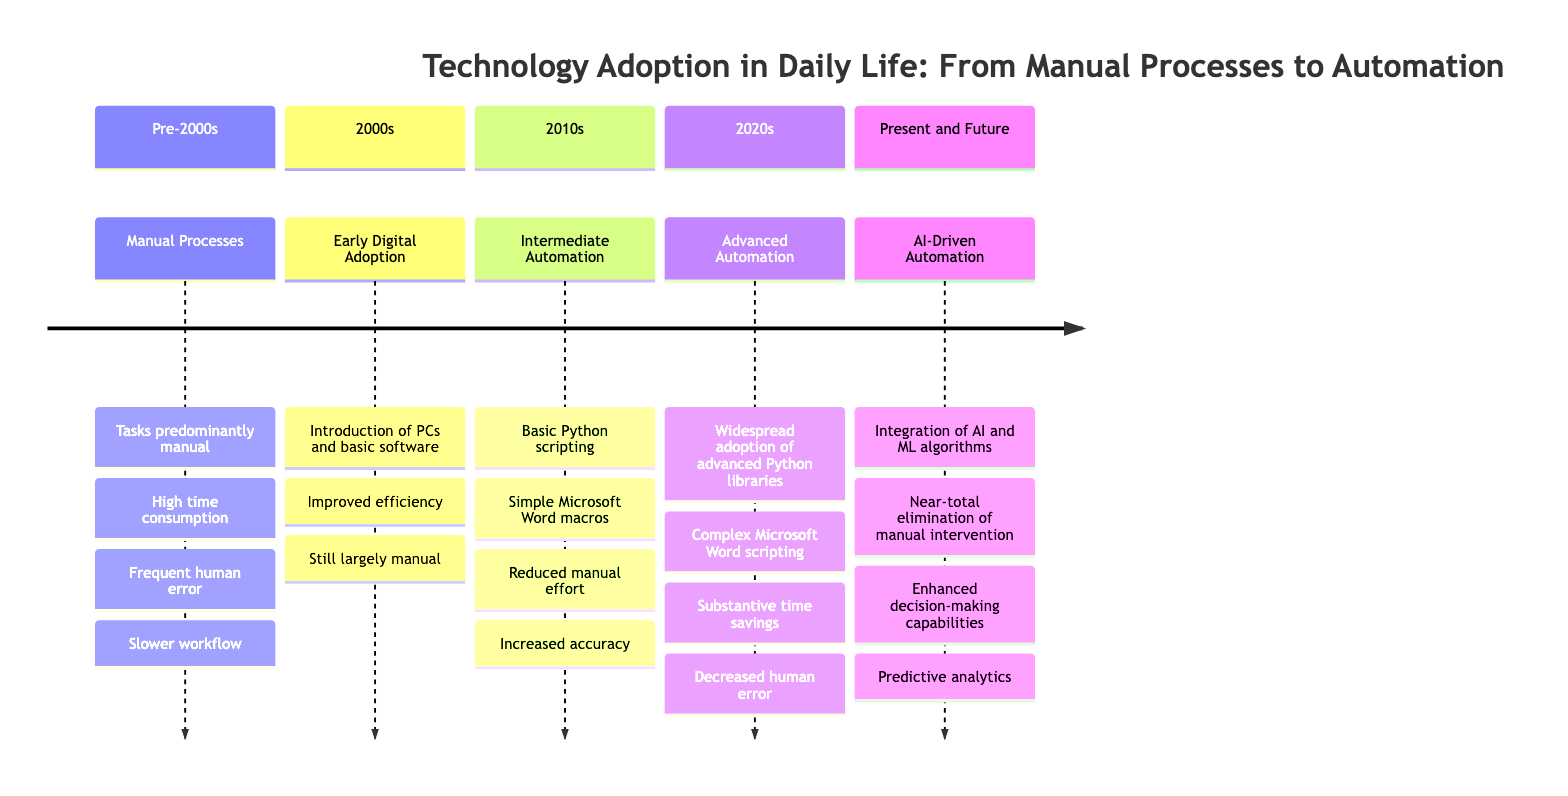What stage comes after Intermediate Automation with Basic Scripting? Looking at the timeline, we can see that the stage listed after "Intermediate Automation with Basic Scripting" is "Advanced Automation through Integrated Systems."
Answer: Advanced Automation through Integrated Systems What period does Early Digital Adoption belong to? The timeline clearly states that "Early Digital Adoption" corresponds to the "2000s" period.
Answer: 2000s How many stages are there in the timeline? By counting the different entries listed in the timeline, we find there are five stages: Manual Processes, Early Digital Adoption, Intermediate Automation with Basic Scripting, Advanced Automation through Integrated Systems, and AI-Driven Automation.
Answer: 5 What was the primary impact of Manual Processes according to the timeline? The timeline indicates that the primary impact was "High time consumption, frequent human error, and slower workflow," which collectively describes the drawbacks of that stage.
Answer: High time consumption, frequent human error, and slower workflow Which technology introduced in the 2000s helped improve efficiency in document production? The timeline attributes the improvement in document production efficiency to the "personal computers and basic software like Microsoft Office Suite" that were introduced during the 2000s.
Answer: Personal computers and basic software like Microsoft Office Suite What significant change occurred during the 2020s in automation technologies? The timeline shows that during the 2020s, there was a "widespread adoption of advanced Python libraries (e.g., pandas, numpy) and complex Microsoft Word scripting," indicating a substantial evolution in automation capabilities.
Answer: Widespread adoption of advanced Python libraries and complex Microsoft Word scripting How does AI-Driven Automation impact manual intervention? Referring to the timeline, it states that AI-Driven Automation leads to a "near-total elimination of manual intervention for routine, repetitive tasks," highlighting its profound effect on automation processes.
Answer: Near-total elimination of manual intervention What is a characteristic of Intermediate Automation with Basic Scripting? According to the timeline, a characteristic of this stage is the use of "basic Python scripting and simple Microsoft Word macros," which contributed to increased accuracy and a reduction in manual effort.
Answer: Basic Python scripting and simple Microsoft Word macros 